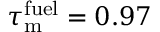<formula> <loc_0><loc_0><loc_500><loc_500>\tau _ { m } ^ { f u e l } = 0 . 9 7</formula> 